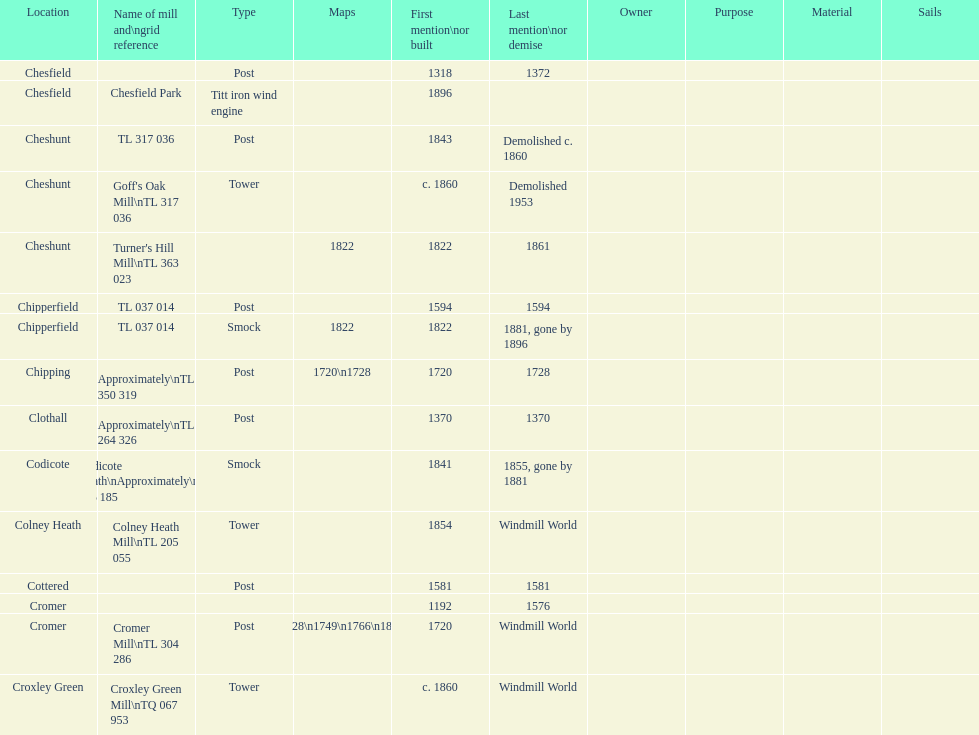How many mills were built or first mentioned after 1800? 8. Can you give me this table as a dict? {'header': ['Location', 'Name of mill and\\ngrid reference', 'Type', 'Maps', 'First mention\\nor built', 'Last mention\\nor demise', 'Owner', 'Purpose', 'Material', 'Sails'], 'rows': [['Chesfield', '', 'Post', '', '1318', '1372', '', '', '', ''], ['Chesfield', 'Chesfield Park', 'Titt iron wind engine', '', '1896', '', '', '', '', ''], ['Cheshunt', 'TL 317 036', 'Post', '', '1843', 'Demolished c. 1860', '', '', '', ''], ['Cheshunt', "Goff's Oak Mill\\nTL 317 036", 'Tower', '', 'c. 1860', 'Demolished 1953', '', '', '', ''], ['Cheshunt', "Turner's Hill Mill\\nTL 363 023", '', '1822', '1822', '1861', '', '', '', ''], ['Chipperfield', 'TL 037 014', 'Post', '', '1594', '1594', '', '', '', ''], ['Chipperfield', 'TL 037 014', 'Smock', '1822', '1822', '1881, gone by 1896', '', '', '', ''], ['Chipping', 'Approximately\\nTL 350 319', 'Post', '1720\\n1728', '1720', '1728', '', '', '', ''], ['Clothall', 'Approximately\\nTL 264 326', 'Post', '', '1370', '1370', '', '', '', ''], ['Codicote', 'Codicote Heath\\nApproximately\\nTL 206 185', 'Smock', '', '1841', '1855, gone by 1881', '', '', '', ''], ['Colney Heath', 'Colney Heath Mill\\nTL 205 055', 'Tower', '', '1854', 'Windmill World', '', '', '', ''], ['Cottered', '', 'Post', '', '1581', '1581', '', '', '', ''], ['Cromer', '', '', '', '1192', '1576', '', '', '', ''], ['Cromer', 'Cromer Mill\\nTL 304 286', 'Post', '1720\\n1728\\n1749\\n1766\\n1800\\n1822', '1720', 'Windmill World', '', '', '', ''], ['Croxley Green', 'Croxley Green Mill\\nTQ 067 953', 'Tower', '', 'c. 1860', 'Windmill World', '', '', '', '']]} 